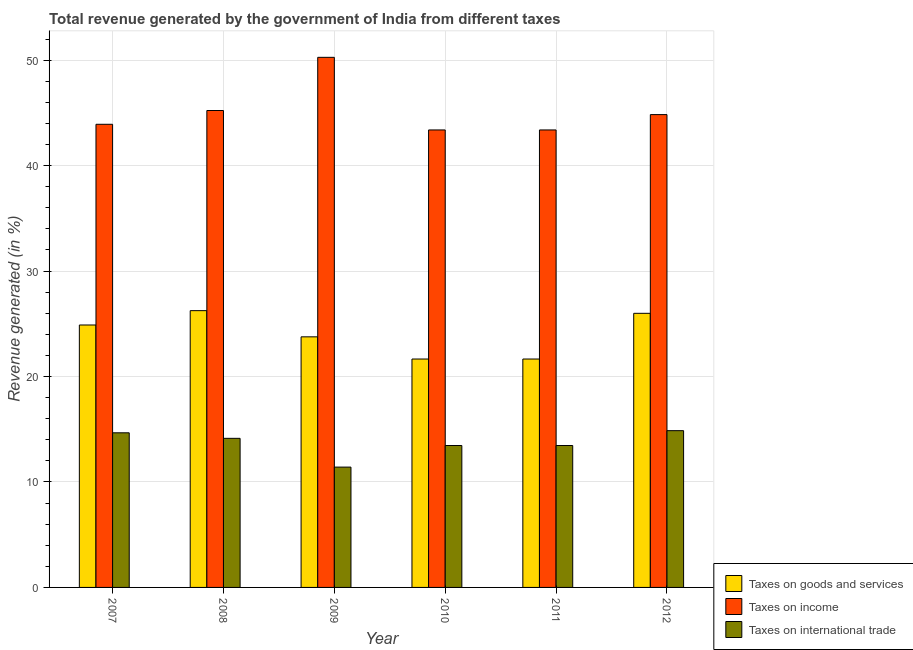How many groups of bars are there?
Keep it short and to the point. 6. Are the number of bars per tick equal to the number of legend labels?
Make the answer very short. Yes. Are the number of bars on each tick of the X-axis equal?
Provide a short and direct response. Yes. How many bars are there on the 2nd tick from the left?
Your response must be concise. 3. How many bars are there on the 6th tick from the right?
Make the answer very short. 3. What is the label of the 2nd group of bars from the left?
Keep it short and to the point. 2008. What is the percentage of revenue generated by taxes on goods and services in 2008?
Give a very brief answer. 26.25. Across all years, what is the maximum percentage of revenue generated by taxes on income?
Give a very brief answer. 50.27. Across all years, what is the minimum percentage of revenue generated by taxes on goods and services?
Keep it short and to the point. 21.66. In which year was the percentage of revenue generated by taxes on income minimum?
Your response must be concise. 2010. What is the total percentage of revenue generated by taxes on goods and services in the graph?
Your response must be concise. 144.22. What is the difference between the percentage of revenue generated by tax on international trade in 2007 and that in 2009?
Provide a succinct answer. 3.25. What is the difference between the percentage of revenue generated by taxes on income in 2007 and the percentage of revenue generated by tax on international trade in 2012?
Your answer should be compact. -0.92. What is the average percentage of revenue generated by taxes on income per year?
Ensure brevity in your answer.  45.17. In how many years, is the percentage of revenue generated by taxes on goods and services greater than 22 %?
Ensure brevity in your answer.  4. What is the ratio of the percentage of revenue generated by tax on international trade in 2010 to that in 2012?
Keep it short and to the point. 0.91. Is the percentage of revenue generated by taxes on income in 2008 less than that in 2012?
Keep it short and to the point. No. What is the difference between the highest and the second highest percentage of revenue generated by taxes on income?
Give a very brief answer. 5.04. What is the difference between the highest and the lowest percentage of revenue generated by tax on international trade?
Give a very brief answer. 3.46. Is the sum of the percentage of revenue generated by taxes on goods and services in 2010 and 2011 greater than the maximum percentage of revenue generated by tax on international trade across all years?
Keep it short and to the point. Yes. What does the 3rd bar from the left in 2008 represents?
Provide a short and direct response. Taxes on international trade. What does the 1st bar from the right in 2007 represents?
Provide a short and direct response. Taxes on international trade. How many years are there in the graph?
Your response must be concise. 6. Does the graph contain any zero values?
Offer a very short reply. No. Does the graph contain grids?
Offer a terse response. Yes. How are the legend labels stacked?
Make the answer very short. Vertical. What is the title of the graph?
Make the answer very short. Total revenue generated by the government of India from different taxes. Does "Secondary education" appear as one of the legend labels in the graph?
Keep it short and to the point. No. What is the label or title of the X-axis?
Make the answer very short. Year. What is the label or title of the Y-axis?
Provide a short and direct response. Revenue generated (in %). What is the Revenue generated (in %) of Taxes on goods and services in 2007?
Offer a very short reply. 24.89. What is the Revenue generated (in %) in Taxes on income in 2007?
Give a very brief answer. 43.92. What is the Revenue generated (in %) of Taxes on international trade in 2007?
Offer a very short reply. 14.66. What is the Revenue generated (in %) of Taxes on goods and services in 2008?
Make the answer very short. 26.25. What is the Revenue generated (in %) in Taxes on income in 2008?
Your answer should be compact. 45.23. What is the Revenue generated (in %) of Taxes on international trade in 2008?
Offer a very short reply. 14.14. What is the Revenue generated (in %) in Taxes on goods and services in 2009?
Provide a succinct answer. 23.76. What is the Revenue generated (in %) of Taxes on income in 2009?
Your answer should be compact. 50.27. What is the Revenue generated (in %) of Taxes on international trade in 2009?
Ensure brevity in your answer.  11.41. What is the Revenue generated (in %) of Taxes on goods and services in 2010?
Make the answer very short. 21.66. What is the Revenue generated (in %) in Taxes on income in 2010?
Provide a succinct answer. 43.38. What is the Revenue generated (in %) in Taxes on international trade in 2010?
Offer a very short reply. 13.46. What is the Revenue generated (in %) of Taxes on goods and services in 2011?
Offer a terse response. 21.66. What is the Revenue generated (in %) of Taxes on income in 2011?
Provide a succinct answer. 43.38. What is the Revenue generated (in %) in Taxes on international trade in 2011?
Provide a succinct answer. 13.46. What is the Revenue generated (in %) of Taxes on goods and services in 2012?
Your answer should be very brief. 25.99. What is the Revenue generated (in %) in Taxes on income in 2012?
Make the answer very short. 44.84. What is the Revenue generated (in %) in Taxes on international trade in 2012?
Offer a terse response. 14.87. Across all years, what is the maximum Revenue generated (in %) of Taxes on goods and services?
Your response must be concise. 26.25. Across all years, what is the maximum Revenue generated (in %) of Taxes on income?
Offer a terse response. 50.27. Across all years, what is the maximum Revenue generated (in %) of Taxes on international trade?
Provide a short and direct response. 14.87. Across all years, what is the minimum Revenue generated (in %) in Taxes on goods and services?
Give a very brief answer. 21.66. Across all years, what is the minimum Revenue generated (in %) in Taxes on income?
Your answer should be compact. 43.38. Across all years, what is the minimum Revenue generated (in %) of Taxes on international trade?
Keep it short and to the point. 11.41. What is the total Revenue generated (in %) in Taxes on goods and services in the graph?
Offer a terse response. 144.22. What is the total Revenue generated (in %) in Taxes on income in the graph?
Your response must be concise. 271.03. What is the total Revenue generated (in %) in Taxes on international trade in the graph?
Ensure brevity in your answer.  82. What is the difference between the Revenue generated (in %) of Taxes on goods and services in 2007 and that in 2008?
Give a very brief answer. -1.36. What is the difference between the Revenue generated (in %) of Taxes on income in 2007 and that in 2008?
Your response must be concise. -1.31. What is the difference between the Revenue generated (in %) of Taxes on international trade in 2007 and that in 2008?
Provide a succinct answer. 0.52. What is the difference between the Revenue generated (in %) of Taxes on goods and services in 2007 and that in 2009?
Provide a short and direct response. 1.12. What is the difference between the Revenue generated (in %) of Taxes on income in 2007 and that in 2009?
Your answer should be very brief. -6.35. What is the difference between the Revenue generated (in %) of Taxes on international trade in 2007 and that in 2009?
Provide a short and direct response. 3.25. What is the difference between the Revenue generated (in %) of Taxes on goods and services in 2007 and that in 2010?
Ensure brevity in your answer.  3.23. What is the difference between the Revenue generated (in %) in Taxes on income in 2007 and that in 2010?
Your answer should be compact. 0.54. What is the difference between the Revenue generated (in %) in Taxes on international trade in 2007 and that in 2010?
Give a very brief answer. 1.21. What is the difference between the Revenue generated (in %) of Taxes on goods and services in 2007 and that in 2011?
Your answer should be very brief. 3.23. What is the difference between the Revenue generated (in %) in Taxes on income in 2007 and that in 2011?
Make the answer very short. 0.54. What is the difference between the Revenue generated (in %) in Taxes on international trade in 2007 and that in 2011?
Offer a terse response. 1.21. What is the difference between the Revenue generated (in %) in Taxes on goods and services in 2007 and that in 2012?
Give a very brief answer. -1.11. What is the difference between the Revenue generated (in %) of Taxes on income in 2007 and that in 2012?
Ensure brevity in your answer.  -0.92. What is the difference between the Revenue generated (in %) in Taxes on international trade in 2007 and that in 2012?
Provide a succinct answer. -0.2. What is the difference between the Revenue generated (in %) of Taxes on goods and services in 2008 and that in 2009?
Offer a terse response. 2.48. What is the difference between the Revenue generated (in %) of Taxes on income in 2008 and that in 2009?
Provide a succinct answer. -5.04. What is the difference between the Revenue generated (in %) in Taxes on international trade in 2008 and that in 2009?
Provide a succinct answer. 2.73. What is the difference between the Revenue generated (in %) of Taxes on goods and services in 2008 and that in 2010?
Give a very brief answer. 4.59. What is the difference between the Revenue generated (in %) of Taxes on income in 2008 and that in 2010?
Your answer should be compact. 1.84. What is the difference between the Revenue generated (in %) in Taxes on international trade in 2008 and that in 2010?
Keep it short and to the point. 0.68. What is the difference between the Revenue generated (in %) of Taxes on goods and services in 2008 and that in 2011?
Make the answer very short. 4.59. What is the difference between the Revenue generated (in %) of Taxes on income in 2008 and that in 2011?
Make the answer very short. 1.84. What is the difference between the Revenue generated (in %) of Taxes on international trade in 2008 and that in 2011?
Make the answer very short. 0.68. What is the difference between the Revenue generated (in %) in Taxes on goods and services in 2008 and that in 2012?
Provide a succinct answer. 0.25. What is the difference between the Revenue generated (in %) of Taxes on income in 2008 and that in 2012?
Provide a short and direct response. 0.39. What is the difference between the Revenue generated (in %) of Taxes on international trade in 2008 and that in 2012?
Offer a very short reply. -0.73. What is the difference between the Revenue generated (in %) of Taxes on goods and services in 2009 and that in 2010?
Offer a terse response. 2.1. What is the difference between the Revenue generated (in %) of Taxes on income in 2009 and that in 2010?
Offer a very short reply. 6.89. What is the difference between the Revenue generated (in %) in Taxes on international trade in 2009 and that in 2010?
Your response must be concise. -2.05. What is the difference between the Revenue generated (in %) of Taxes on goods and services in 2009 and that in 2011?
Keep it short and to the point. 2.1. What is the difference between the Revenue generated (in %) of Taxes on income in 2009 and that in 2011?
Offer a very short reply. 6.89. What is the difference between the Revenue generated (in %) in Taxes on international trade in 2009 and that in 2011?
Offer a terse response. -2.05. What is the difference between the Revenue generated (in %) in Taxes on goods and services in 2009 and that in 2012?
Offer a terse response. -2.23. What is the difference between the Revenue generated (in %) of Taxes on income in 2009 and that in 2012?
Keep it short and to the point. 5.43. What is the difference between the Revenue generated (in %) in Taxes on international trade in 2009 and that in 2012?
Keep it short and to the point. -3.46. What is the difference between the Revenue generated (in %) in Taxes on goods and services in 2010 and that in 2011?
Provide a short and direct response. 0. What is the difference between the Revenue generated (in %) of Taxes on goods and services in 2010 and that in 2012?
Provide a succinct answer. -4.33. What is the difference between the Revenue generated (in %) in Taxes on income in 2010 and that in 2012?
Offer a very short reply. -1.45. What is the difference between the Revenue generated (in %) in Taxes on international trade in 2010 and that in 2012?
Keep it short and to the point. -1.41. What is the difference between the Revenue generated (in %) in Taxes on goods and services in 2011 and that in 2012?
Keep it short and to the point. -4.33. What is the difference between the Revenue generated (in %) of Taxes on income in 2011 and that in 2012?
Ensure brevity in your answer.  -1.45. What is the difference between the Revenue generated (in %) of Taxes on international trade in 2011 and that in 2012?
Ensure brevity in your answer.  -1.41. What is the difference between the Revenue generated (in %) in Taxes on goods and services in 2007 and the Revenue generated (in %) in Taxes on income in 2008?
Your answer should be compact. -20.34. What is the difference between the Revenue generated (in %) in Taxes on goods and services in 2007 and the Revenue generated (in %) in Taxes on international trade in 2008?
Give a very brief answer. 10.75. What is the difference between the Revenue generated (in %) in Taxes on income in 2007 and the Revenue generated (in %) in Taxes on international trade in 2008?
Your answer should be very brief. 29.78. What is the difference between the Revenue generated (in %) of Taxes on goods and services in 2007 and the Revenue generated (in %) of Taxes on income in 2009?
Offer a terse response. -25.38. What is the difference between the Revenue generated (in %) in Taxes on goods and services in 2007 and the Revenue generated (in %) in Taxes on international trade in 2009?
Your answer should be very brief. 13.48. What is the difference between the Revenue generated (in %) of Taxes on income in 2007 and the Revenue generated (in %) of Taxes on international trade in 2009?
Offer a terse response. 32.51. What is the difference between the Revenue generated (in %) of Taxes on goods and services in 2007 and the Revenue generated (in %) of Taxes on income in 2010?
Provide a succinct answer. -18.5. What is the difference between the Revenue generated (in %) in Taxes on goods and services in 2007 and the Revenue generated (in %) in Taxes on international trade in 2010?
Offer a very short reply. 11.43. What is the difference between the Revenue generated (in %) of Taxes on income in 2007 and the Revenue generated (in %) of Taxes on international trade in 2010?
Your answer should be very brief. 30.46. What is the difference between the Revenue generated (in %) in Taxes on goods and services in 2007 and the Revenue generated (in %) in Taxes on income in 2011?
Your answer should be compact. -18.5. What is the difference between the Revenue generated (in %) in Taxes on goods and services in 2007 and the Revenue generated (in %) in Taxes on international trade in 2011?
Provide a succinct answer. 11.43. What is the difference between the Revenue generated (in %) in Taxes on income in 2007 and the Revenue generated (in %) in Taxes on international trade in 2011?
Keep it short and to the point. 30.46. What is the difference between the Revenue generated (in %) of Taxes on goods and services in 2007 and the Revenue generated (in %) of Taxes on income in 2012?
Keep it short and to the point. -19.95. What is the difference between the Revenue generated (in %) of Taxes on goods and services in 2007 and the Revenue generated (in %) of Taxes on international trade in 2012?
Offer a terse response. 10.02. What is the difference between the Revenue generated (in %) of Taxes on income in 2007 and the Revenue generated (in %) of Taxes on international trade in 2012?
Offer a terse response. 29.05. What is the difference between the Revenue generated (in %) in Taxes on goods and services in 2008 and the Revenue generated (in %) in Taxes on income in 2009?
Offer a very short reply. -24.02. What is the difference between the Revenue generated (in %) in Taxes on goods and services in 2008 and the Revenue generated (in %) in Taxes on international trade in 2009?
Provide a short and direct response. 14.84. What is the difference between the Revenue generated (in %) in Taxes on income in 2008 and the Revenue generated (in %) in Taxes on international trade in 2009?
Keep it short and to the point. 33.82. What is the difference between the Revenue generated (in %) of Taxes on goods and services in 2008 and the Revenue generated (in %) of Taxes on income in 2010?
Keep it short and to the point. -17.14. What is the difference between the Revenue generated (in %) of Taxes on goods and services in 2008 and the Revenue generated (in %) of Taxes on international trade in 2010?
Make the answer very short. 12.79. What is the difference between the Revenue generated (in %) in Taxes on income in 2008 and the Revenue generated (in %) in Taxes on international trade in 2010?
Your response must be concise. 31.77. What is the difference between the Revenue generated (in %) of Taxes on goods and services in 2008 and the Revenue generated (in %) of Taxes on income in 2011?
Keep it short and to the point. -17.14. What is the difference between the Revenue generated (in %) of Taxes on goods and services in 2008 and the Revenue generated (in %) of Taxes on international trade in 2011?
Your answer should be compact. 12.79. What is the difference between the Revenue generated (in %) of Taxes on income in 2008 and the Revenue generated (in %) of Taxes on international trade in 2011?
Your answer should be compact. 31.77. What is the difference between the Revenue generated (in %) of Taxes on goods and services in 2008 and the Revenue generated (in %) of Taxes on income in 2012?
Make the answer very short. -18.59. What is the difference between the Revenue generated (in %) of Taxes on goods and services in 2008 and the Revenue generated (in %) of Taxes on international trade in 2012?
Offer a very short reply. 11.38. What is the difference between the Revenue generated (in %) in Taxes on income in 2008 and the Revenue generated (in %) in Taxes on international trade in 2012?
Give a very brief answer. 30.36. What is the difference between the Revenue generated (in %) in Taxes on goods and services in 2009 and the Revenue generated (in %) in Taxes on income in 2010?
Offer a very short reply. -19.62. What is the difference between the Revenue generated (in %) of Taxes on goods and services in 2009 and the Revenue generated (in %) of Taxes on international trade in 2010?
Offer a very short reply. 10.31. What is the difference between the Revenue generated (in %) of Taxes on income in 2009 and the Revenue generated (in %) of Taxes on international trade in 2010?
Your answer should be very brief. 36.81. What is the difference between the Revenue generated (in %) of Taxes on goods and services in 2009 and the Revenue generated (in %) of Taxes on income in 2011?
Offer a very short reply. -19.62. What is the difference between the Revenue generated (in %) in Taxes on goods and services in 2009 and the Revenue generated (in %) in Taxes on international trade in 2011?
Offer a very short reply. 10.31. What is the difference between the Revenue generated (in %) in Taxes on income in 2009 and the Revenue generated (in %) in Taxes on international trade in 2011?
Give a very brief answer. 36.81. What is the difference between the Revenue generated (in %) of Taxes on goods and services in 2009 and the Revenue generated (in %) of Taxes on income in 2012?
Offer a very short reply. -21.07. What is the difference between the Revenue generated (in %) in Taxes on goods and services in 2009 and the Revenue generated (in %) in Taxes on international trade in 2012?
Ensure brevity in your answer.  8.9. What is the difference between the Revenue generated (in %) in Taxes on income in 2009 and the Revenue generated (in %) in Taxes on international trade in 2012?
Ensure brevity in your answer.  35.4. What is the difference between the Revenue generated (in %) of Taxes on goods and services in 2010 and the Revenue generated (in %) of Taxes on income in 2011?
Keep it short and to the point. -21.72. What is the difference between the Revenue generated (in %) of Taxes on goods and services in 2010 and the Revenue generated (in %) of Taxes on international trade in 2011?
Offer a very short reply. 8.2. What is the difference between the Revenue generated (in %) of Taxes on income in 2010 and the Revenue generated (in %) of Taxes on international trade in 2011?
Provide a short and direct response. 29.93. What is the difference between the Revenue generated (in %) in Taxes on goods and services in 2010 and the Revenue generated (in %) in Taxes on income in 2012?
Make the answer very short. -23.18. What is the difference between the Revenue generated (in %) in Taxes on goods and services in 2010 and the Revenue generated (in %) in Taxes on international trade in 2012?
Ensure brevity in your answer.  6.79. What is the difference between the Revenue generated (in %) in Taxes on income in 2010 and the Revenue generated (in %) in Taxes on international trade in 2012?
Provide a short and direct response. 28.52. What is the difference between the Revenue generated (in %) of Taxes on goods and services in 2011 and the Revenue generated (in %) of Taxes on income in 2012?
Offer a very short reply. -23.18. What is the difference between the Revenue generated (in %) in Taxes on goods and services in 2011 and the Revenue generated (in %) in Taxes on international trade in 2012?
Provide a short and direct response. 6.79. What is the difference between the Revenue generated (in %) of Taxes on income in 2011 and the Revenue generated (in %) of Taxes on international trade in 2012?
Provide a succinct answer. 28.52. What is the average Revenue generated (in %) in Taxes on goods and services per year?
Ensure brevity in your answer.  24.04. What is the average Revenue generated (in %) in Taxes on income per year?
Provide a succinct answer. 45.17. What is the average Revenue generated (in %) of Taxes on international trade per year?
Keep it short and to the point. 13.67. In the year 2007, what is the difference between the Revenue generated (in %) of Taxes on goods and services and Revenue generated (in %) of Taxes on income?
Ensure brevity in your answer.  -19.03. In the year 2007, what is the difference between the Revenue generated (in %) in Taxes on goods and services and Revenue generated (in %) in Taxes on international trade?
Give a very brief answer. 10.22. In the year 2007, what is the difference between the Revenue generated (in %) of Taxes on income and Revenue generated (in %) of Taxes on international trade?
Offer a very short reply. 29.26. In the year 2008, what is the difference between the Revenue generated (in %) of Taxes on goods and services and Revenue generated (in %) of Taxes on income?
Provide a succinct answer. -18.98. In the year 2008, what is the difference between the Revenue generated (in %) in Taxes on goods and services and Revenue generated (in %) in Taxes on international trade?
Your response must be concise. 12.11. In the year 2008, what is the difference between the Revenue generated (in %) in Taxes on income and Revenue generated (in %) in Taxes on international trade?
Your response must be concise. 31.09. In the year 2009, what is the difference between the Revenue generated (in %) in Taxes on goods and services and Revenue generated (in %) in Taxes on income?
Your answer should be compact. -26.51. In the year 2009, what is the difference between the Revenue generated (in %) in Taxes on goods and services and Revenue generated (in %) in Taxes on international trade?
Give a very brief answer. 12.35. In the year 2009, what is the difference between the Revenue generated (in %) of Taxes on income and Revenue generated (in %) of Taxes on international trade?
Offer a very short reply. 38.86. In the year 2010, what is the difference between the Revenue generated (in %) of Taxes on goods and services and Revenue generated (in %) of Taxes on income?
Your response must be concise. -21.72. In the year 2010, what is the difference between the Revenue generated (in %) in Taxes on goods and services and Revenue generated (in %) in Taxes on international trade?
Offer a very short reply. 8.2. In the year 2010, what is the difference between the Revenue generated (in %) in Taxes on income and Revenue generated (in %) in Taxes on international trade?
Give a very brief answer. 29.93. In the year 2011, what is the difference between the Revenue generated (in %) in Taxes on goods and services and Revenue generated (in %) in Taxes on income?
Give a very brief answer. -21.72. In the year 2011, what is the difference between the Revenue generated (in %) in Taxes on goods and services and Revenue generated (in %) in Taxes on international trade?
Your answer should be very brief. 8.2. In the year 2011, what is the difference between the Revenue generated (in %) in Taxes on income and Revenue generated (in %) in Taxes on international trade?
Provide a short and direct response. 29.93. In the year 2012, what is the difference between the Revenue generated (in %) of Taxes on goods and services and Revenue generated (in %) of Taxes on income?
Your answer should be very brief. -18.84. In the year 2012, what is the difference between the Revenue generated (in %) in Taxes on goods and services and Revenue generated (in %) in Taxes on international trade?
Your answer should be very brief. 11.13. In the year 2012, what is the difference between the Revenue generated (in %) of Taxes on income and Revenue generated (in %) of Taxes on international trade?
Provide a short and direct response. 29.97. What is the ratio of the Revenue generated (in %) in Taxes on goods and services in 2007 to that in 2008?
Your answer should be very brief. 0.95. What is the ratio of the Revenue generated (in %) of Taxes on income in 2007 to that in 2008?
Your answer should be compact. 0.97. What is the ratio of the Revenue generated (in %) in Taxes on international trade in 2007 to that in 2008?
Offer a terse response. 1.04. What is the ratio of the Revenue generated (in %) in Taxes on goods and services in 2007 to that in 2009?
Keep it short and to the point. 1.05. What is the ratio of the Revenue generated (in %) of Taxes on income in 2007 to that in 2009?
Offer a very short reply. 0.87. What is the ratio of the Revenue generated (in %) of Taxes on international trade in 2007 to that in 2009?
Ensure brevity in your answer.  1.28. What is the ratio of the Revenue generated (in %) of Taxes on goods and services in 2007 to that in 2010?
Provide a short and direct response. 1.15. What is the ratio of the Revenue generated (in %) in Taxes on income in 2007 to that in 2010?
Keep it short and to the point. 1.01. What is the ratio of the Revenue generated (in %) of Taxes on international trade in 2007 to that in 2010?
Keep it short and to the point. 1.09. What is the ratio of the Revenue generated (in %) of Taxes on goods and services in 2007 to that in 2011?
Provide a succinct answer. 1.15. What is the ratio of the Revenue generated (in %) of Taxes on income in 2007 to that in 2011?
Offer a terse response. 1.01. What is the ratio of the Revenue generated (in %) in Taxes on international trade in 2007 to that in 2011?
Your response must be concise. 1.09. What is the ratio of the Revenue generated (in %) in Taxes on goods and services in 2007 to that in 2012?
Make the answer very short. 0.96. What is the ratio of the Revenue generated (in %) in Taxes on income in 2007 to that in 2012?
Make the answer very short. 0.98. What is the ratio of the Revenue generated (in %) in Taxes on international trade in 2007 to that in 2012?
Keep it short and to the point. 0.99. What is the ratio of the Revenue generated (in %) of Taxes on goods and services in 2008 to that in 2009?
Offer a terse response. 1.1. What is the ratio of the Revenue generated (in %) in Taxes on income in 2008 to that in 2009?
Your response must be concise. 0.9. What is the ratio of the Revenue generated (in %) in Taxes on international trade in 2008 to that in 2009?
Keep it short and to the point. 1.24. What is the ratio of the Revenue generated (in %) of Taxes on goods and services in 2008 to that in 2010?
Provide a short and direct response. 1.21. What is the ratio of the Revenue generated (in %) in Taxes on income in 2008 to that in 2010?
Keep it short and to the point. 1.04. What is the ratio of the Revenue generated (in %) of Taxes on international trade in 2008 to that in 2010?
Keep it short and to the point. 1.05. What is the ratio of the Revenue generated (in %) in Taxes on goods and services in 2008 to that in 2011?
Provide a succinct answer. 1.21. What is the ratio of the Revenue generated (in %) of Taxes on income in 2008 to that in 2011?
Ensure brevity in your answer.  1.04. What is the ratio of the Revenue generated (in %) of Taxes on international trade in 2008 to that in 2011?
Your response must be concise. 1.05. What is the ratio of the Revenue generated (in %) in Taxes on goods and services in 2008 to that in 2012?
Give a very brief answer. 1.01. What is the ratio of the Revenue generated (in %) of Taxes on income in 2008 to that in 2012?
Give a very brief answer. 1.01. What is the ratio of the Revenue generated (in %) of Taxes on international trade in 2008 to that in 2012?
Offer a terse response. 0.95. What is the ratio of the Revenue generated (in %) in Taxes on goods and services in 2009 to that in 2010?
Provide a succinct answer. 1.1. What is the ratio of the Revenue generated (in %) in Taxes on income in 2009 to that in 2010?
Your answer should be compact. 1.16. What is the ratio of the Revenue generated (in %) of Taxes on international trade in 2009 to that in 2010?
Give a very brief answer. 0.85. What is the ratio of the Revenue generated (in %) of Taxes on goods and services in 2009 to that in 2011?
Give a very brief answer. 1.1. What is the ratio of the Revenue generated (in %) of Taxes on income in 2009 to that in 2011?
Offer a terse response. 1.16. What is the ratio of the Revenue generated (in %) in Taxes on international trade in 2009 to that in 2011?
Offer a terse response. 0.85. What is the ratio of the Revenue generated (in %) in Taxes on goods and services in 2009 to that in 2012?
Ensure brevity in your answer.  0.91. What is the ratio of the Revenue generated (in %) of Taxes on income in 2009 to that in 2012?
Ensure brevity in your answer.  1.12. What is the ratio of the Revenue generated (in %) of Taxes on international trade in 2009 to that in 2012?
Make the answer very short. 0.77. What is the ratio of the Revenue generated (in %) of Taxes on goods and services in 2010 to that in 2011?
Your response must be concise. 1. What is the ratio of the Revenue generated (in %) in Taxes on income in 2010 to that in 2011?
Your response must be concise. 1. What is the ratio of the Revenue generated (in %) in Taxes on international trade in 2010 to that in 2011?
Keep it short and to the point. 1. What is the ratio of the Revenue generated (in %) in Taxes on goods and services in 2010 to that in 2012?
Your response must be concise. 0.83. What is the ratio of the Revenue generated (in %) in Taxes on income in 2010 to that in 2012?
Offer a very short reply. 0.97. What is the ratio of the Revenue generated (in %) of Taxes on international trade in 2010 to that in 2012?
Provide a short and direct response. 0.91. What is the ratio of the Revenue generated (in %) in Taxes on income in 2011 to that in 2012?
Make the answer very short. 0.97. What is the ratio of the Revenue generated (in %) in Taxes on international trade in 2011 to that in 2012?
Offer a very short reply. 0.91. What is the difference between the highest and the second highest Revenue generated (in %) of Taxes on goods and services?
Your response must be concise. 0.25. What is the difference between the highest and the second highest Revenue generated (in %) in Taxes on income?
Provide a short and direct response. 5.04. What is the difference between the highest and the second highest Revenue generated (in %) in Taxes on international trade?
Your answer should be very brief. 0.2. What is the difference between the highest and the lowest Revenue generated (in %) of Taxes on goods and services?
Your response must be concise. 4.59. What is the difference between the highest and the lowest Revenue generated (in %) of Taxes on income?
Your answer should be very brief. 6.89. What is the difference between the highest and the lowest Revenue generated (in %) of Taxes on international trade?
Your answer should be very brief. 3.46. 